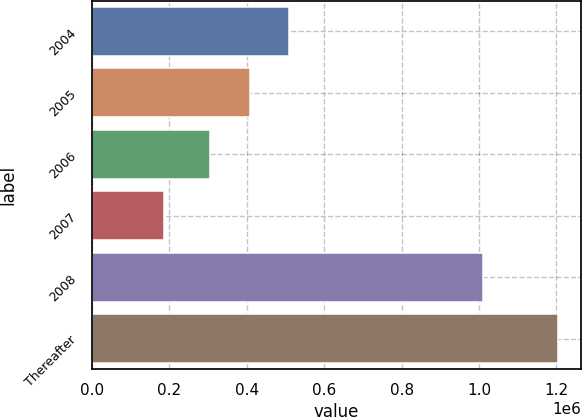Convert chart. <chart><loc_0><loc_0><loc_500><loc_500><bar_chart><fcel>2004<fcel>2005<fcel>2006<fcel>2007<fcel>2008<fcel>Thereafter<nl><fcel>509457<fcel>407639<fcel>305821<fcel>185166<fcel>1.01059e+06<fcel>1.20335e+06<nl></chart> 